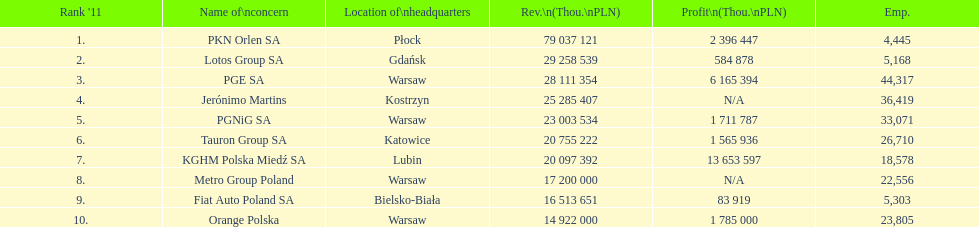What is the difference in employees for rank 1 and rank 3? 39,872 employees. 